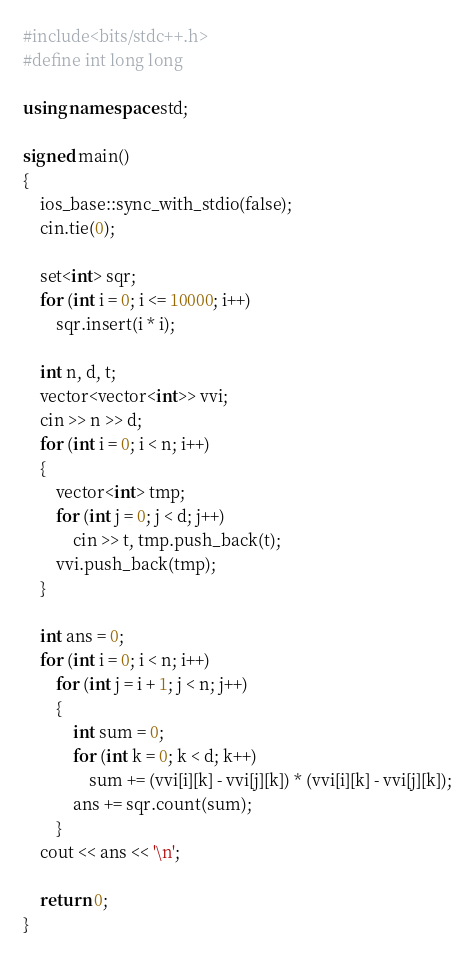<code> <loc_0><loc_0><loc_500><loc_500><_C++_>#include<bits/stdc++.h>
#define int long long

using namespace std;

signed main()
{
    ios_base::sync_with_stdio(false);
    cin.tie(0);

    set<int> sqr;
    for (int i = 0; i <= 10000; i++)
        sqr.insert(i * i);

    int n, d, t;
    vector<vector<int>> vvi;
    cin >> n >> d;
    for (int i = 0; i < n; i++)
    {
        vector<int> tmp;
        for (int j = 0; j < d; j++)
            cin >> t, tmp.push_back(t);
        vvi.push_back(tmp);
    }

    int ans = 0;
    for (int i = 0; i < n; i++)
        for (int j = i + 1; j < n; j++)
        {
            int sum = 0;
            for (int k = 0; k < d; k++)
                sum += (vvi[i][k] - vvi[j][k]) * (vvi[i][k] - vvi[j][k]);
            ans += sqr.count(sum);
        }
    cout << ans << '\n';

    return 0;
}
</code> 